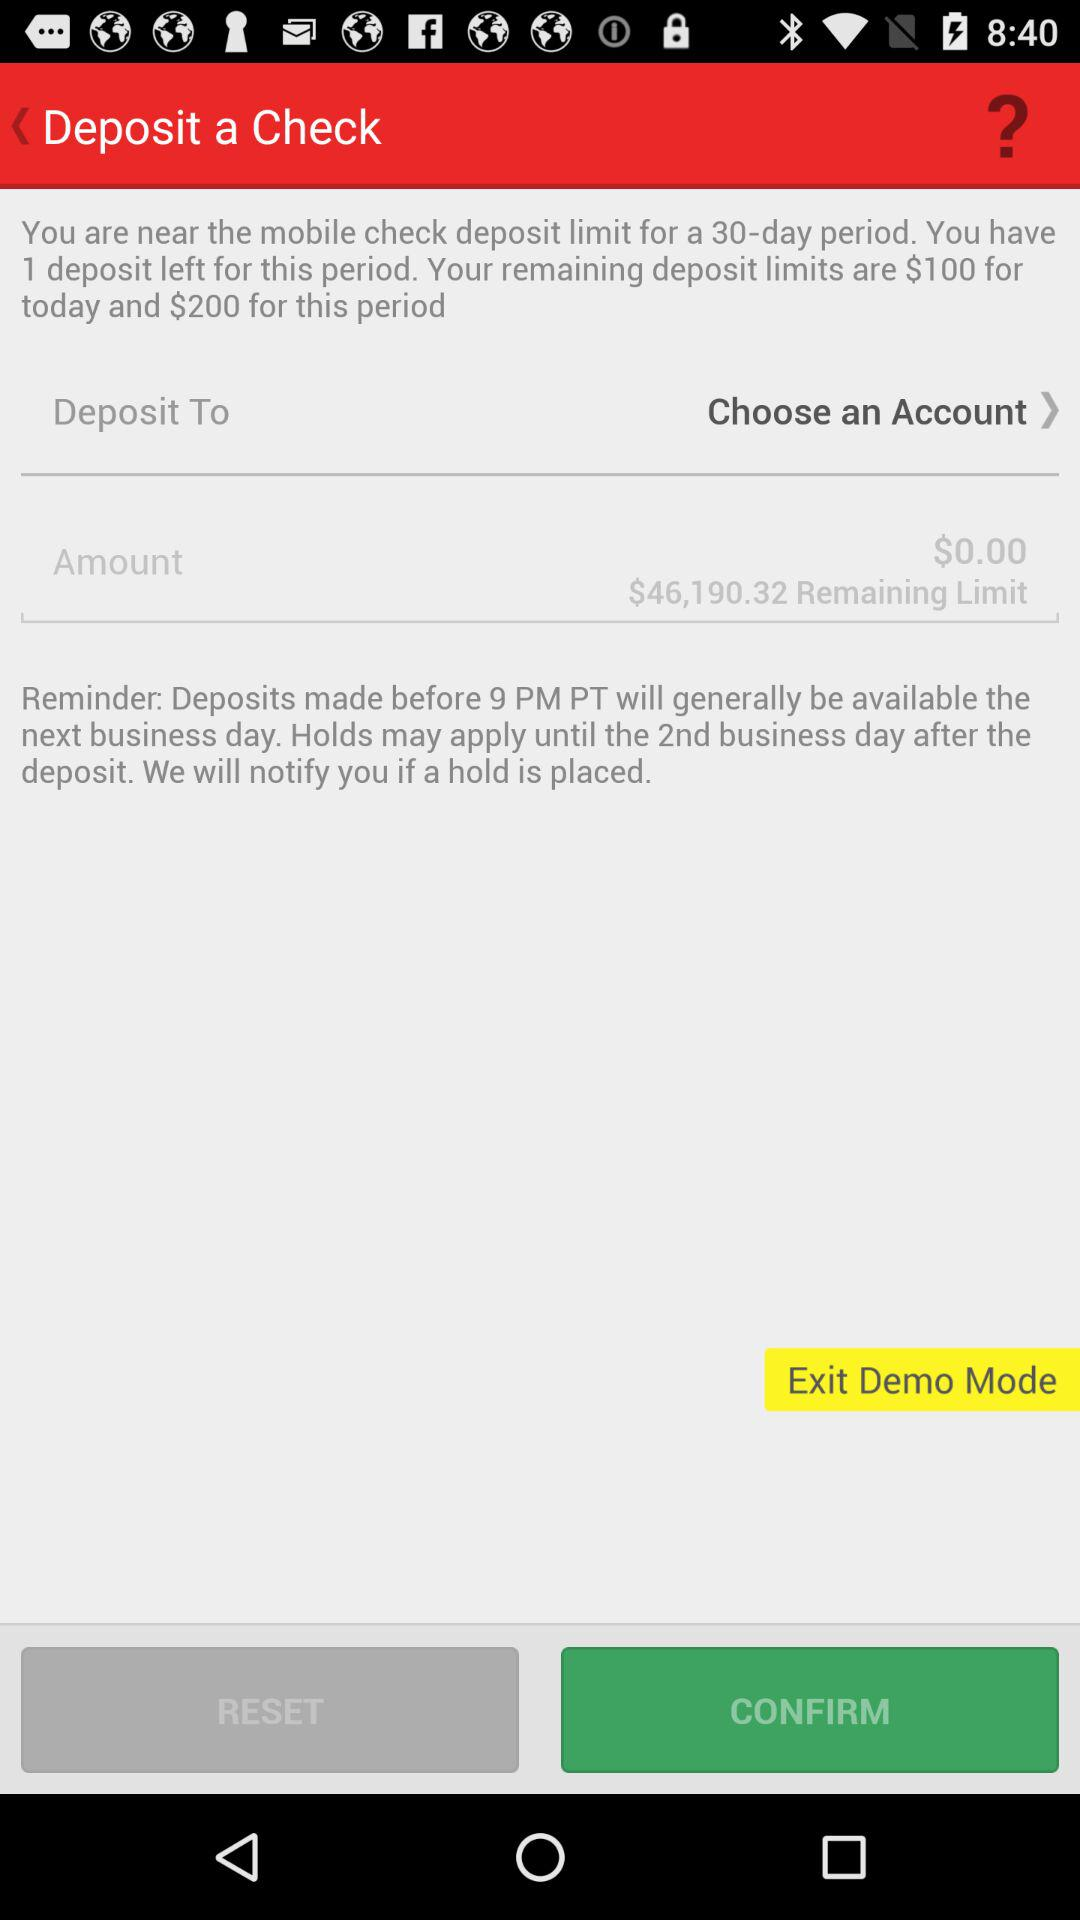What is the remaining limit? The remaining limit is $46,190.32. 